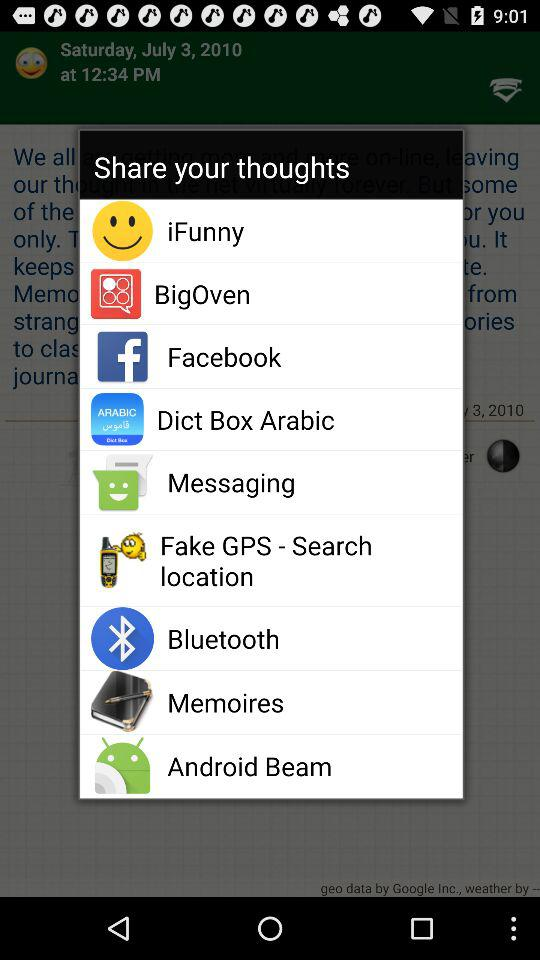Through which app can we share? You can share through "iFunny", "BigOven", "Facebook", "Dict Box Arabic", "Messaging", "Fake GPS - Search location", "Bluetooth", "Memoires" and "Android Beam". 